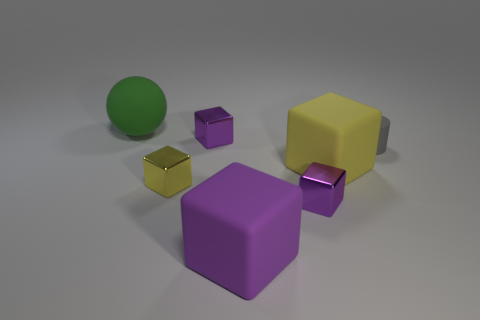Subtract all purple blocks. How many were subtracted if there are1purple blocks left? 2 Subtract all gray cylinders. How many purple cubes are left? 3 Subtract all large purple matte cubes. How many cubes are left? 4 Subtract all cyan blocks. Subtract all blue cylinders. How many blocks are left? 5 Add 1 large purple objects. How many objects exist? 8 Subtract all spheres. How many objects are left? 6 Subtract 0 red balls. How many objects are left? 7 Subtract all tiny gray cylinders. Subtract all purple things. How many objects are left? 3 Add 7 small gray rubber things. How many small gray rubber things are left? 8 Add 5 green spheres. How many green spheres exist? 6 